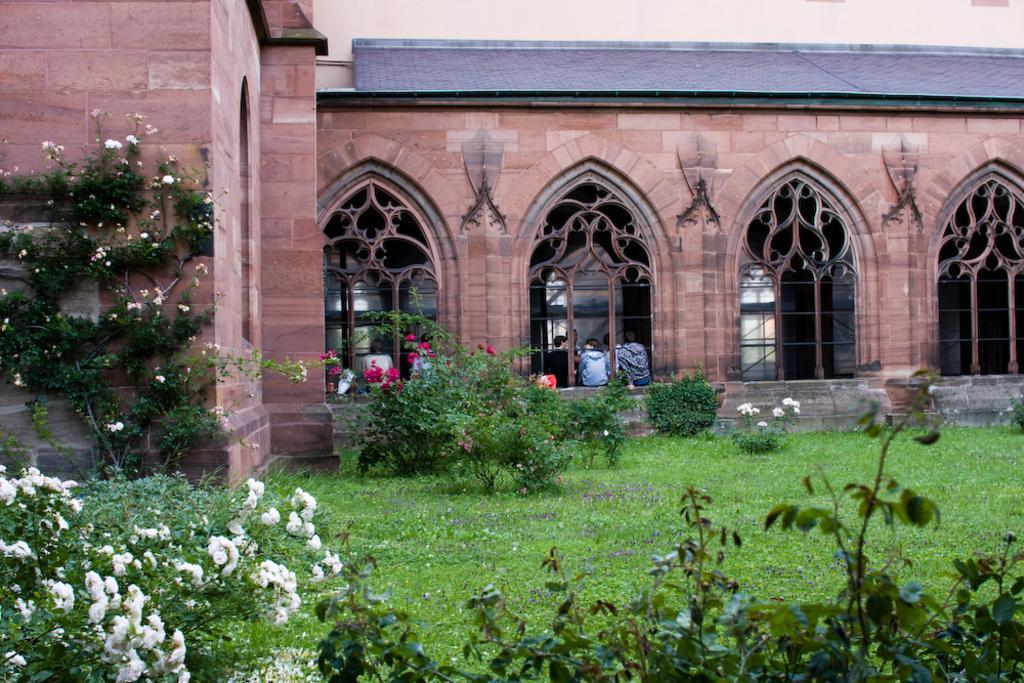Could you give a brief overview of what you see in this image? In this picture, we can see a building with windows, and we can see a few people, we can see the ground with grass, plants and some flowers. 